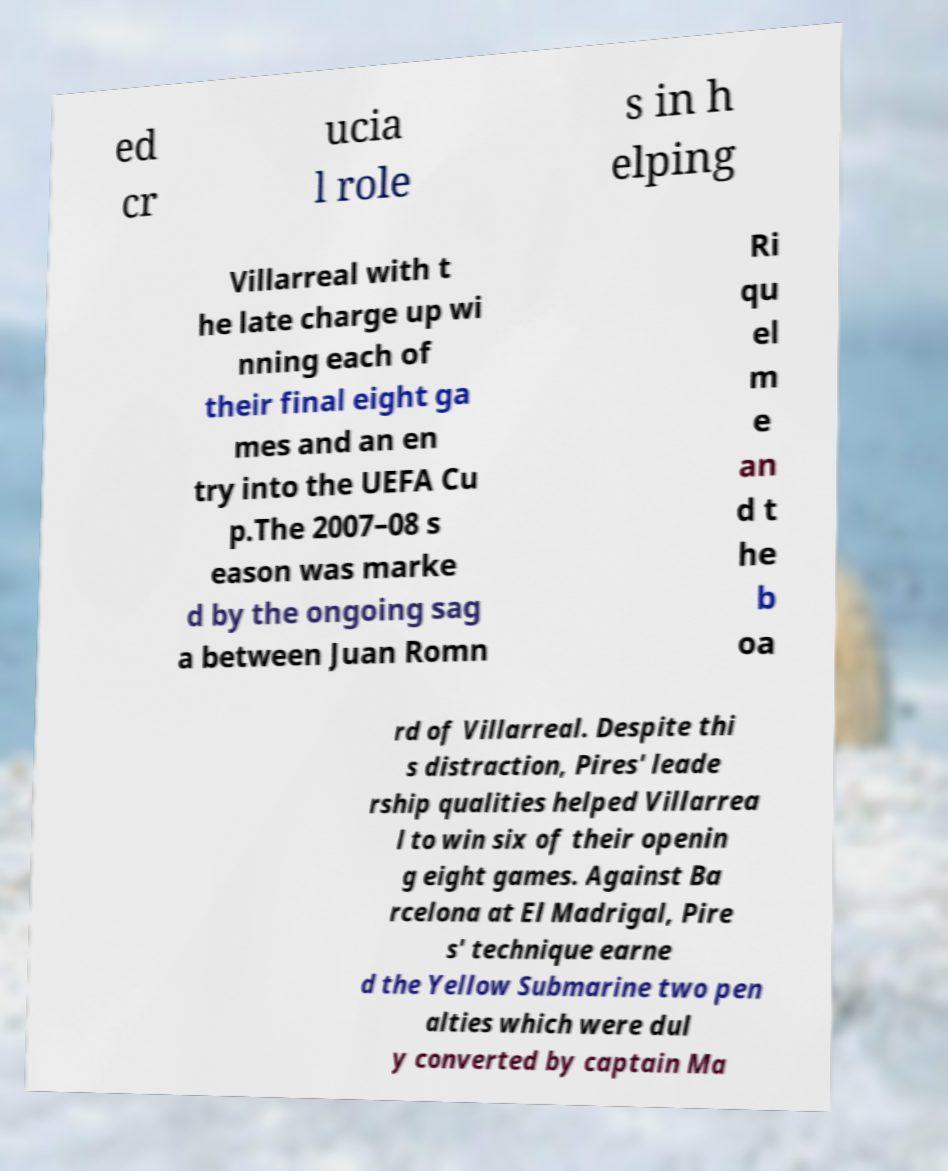Can you read and provide the text displayed in the image?This photo seems to have some interesting text. Can you extract and type it out for me? ed cr ucia l role s in h elping Villarreal with t he late charge up wi nning each of their final eight ga mes and an en try into the UEFA Cu p.The 2007–08 s eason was marke d by the ongoing sag a between Juan Romn Ri qu el m e an d t he b oa rd of Villarreal. Despite thi s distraction, Pires' leade rship qualities helped Villarrea l to win six of their openin g eight games. Against Ba rcelona at El Madrigal, Pire s' technique earne d the Yellow Submarine two pen alties which were dul y converted by captain Ma 